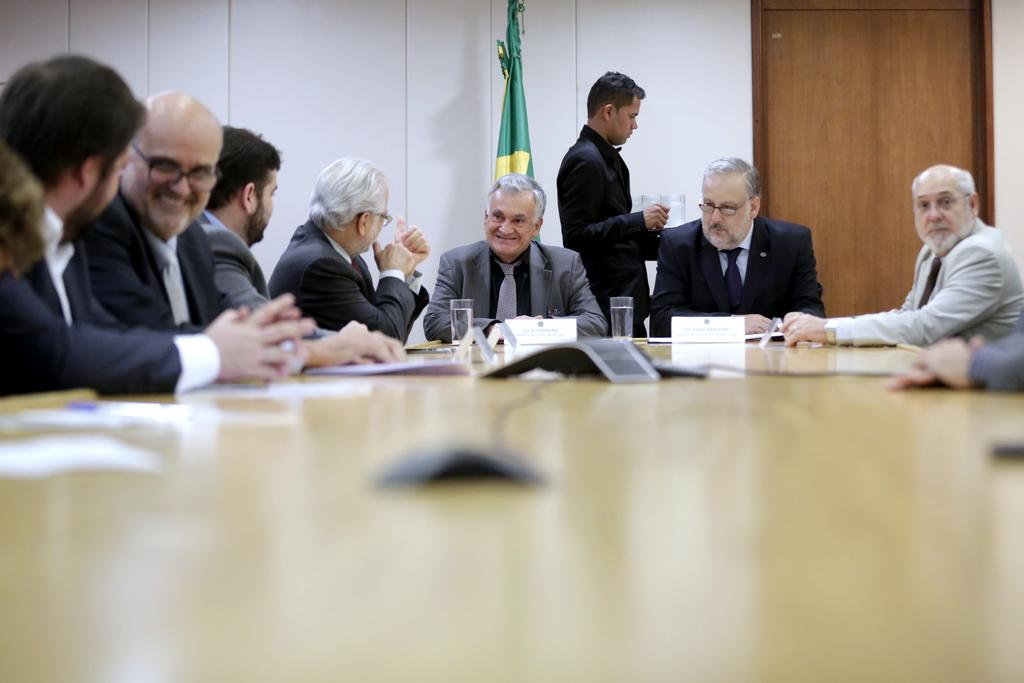What are the people in the image doing? The persons in the image are sitting on chairs. What is on the table in the image? There are papers and glasses on the table. What can be seen in the background of the image? There is a wall, a flag, a door, and a person in the background. What type of wind can be seen blowing through the room in the image? There is no wind present in the image; it is an indoor setting with no visible breeze. 